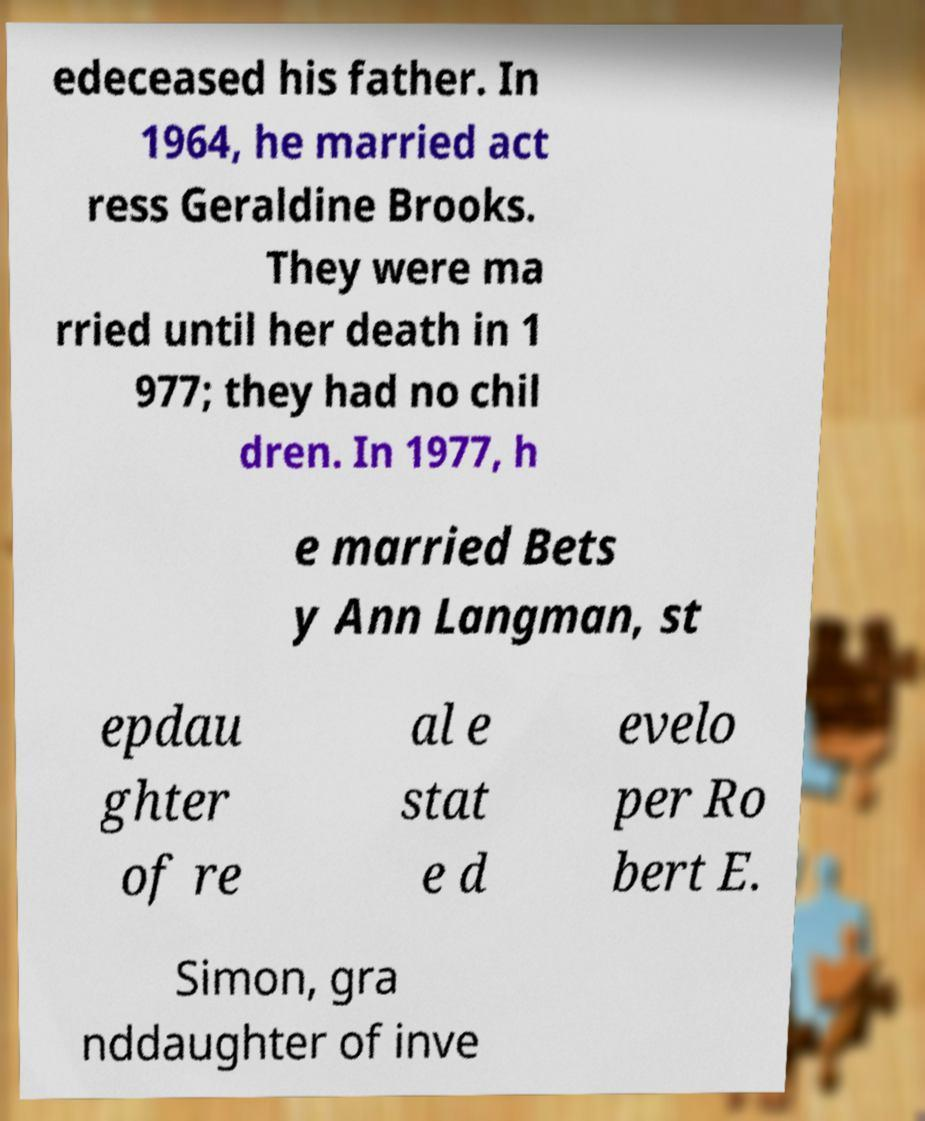Can you accurately transcribe the text from the provided image for me? edeceased his father. In 1964, he married act ress Geraldine Brooks. They were ma rried until her death in 1 977; they had no chil dren. In 1977, h e married Bets y Ann Langman, st epdau ghter of re al e stat e d evelo per Ro bert E. Simon, gra nddaughter of inve 